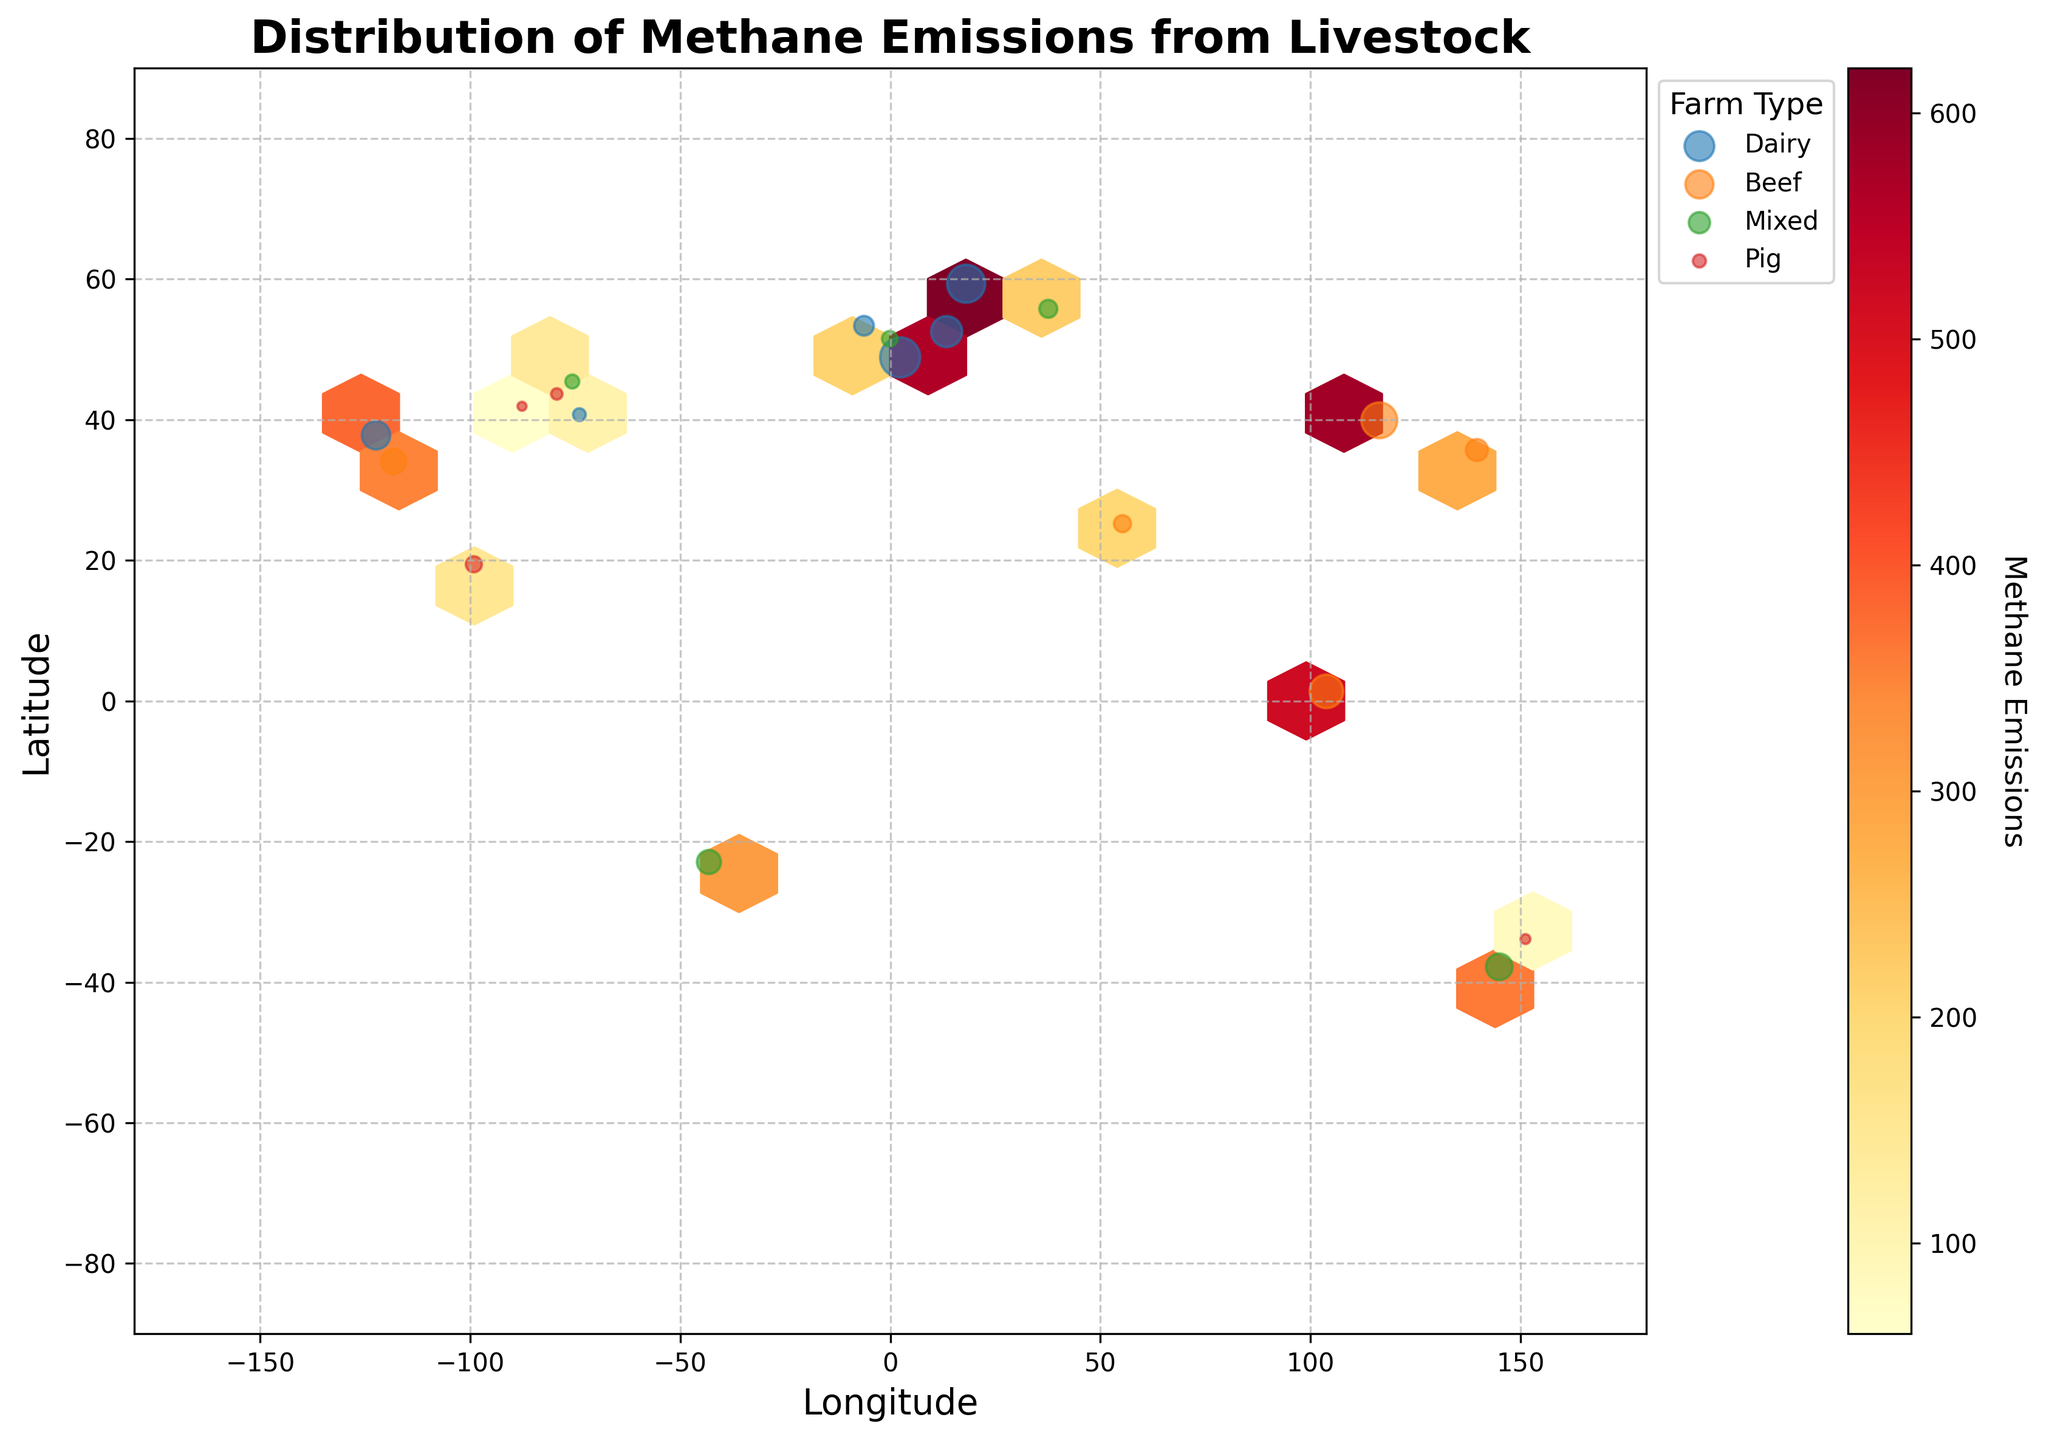What type of farms are represented in the figure? By looking at the legend of the plot, we can see that the farm types indicated are Dairy, Beef, Mixed, and Pig.
Answer: Dairy, Beef, Mixed, Pig What does the color intensity in the Hexbin plot indicate? The color intensity in the Hexbin plot represents the level of methane emissions. The color bar on the right side of the plot ranges from lighter to darker shades, signifying increasing levels of methane emissions.
Answer: Methane emission levels Which farm type primarily has farms with the highest methane emissions? By observing the larger markers and darker color hexagons in the plot, we can identify that Dairy farms are associated with the highest methane emissions.
Answer: Dairy How do methane emissions vary with farm size for Beef farms? By analyzing the scatter points labeled 'Beef', there is a trend where larger Beef farms tend to have higher methane emissions, visible by the larger circle markers over darker-colored hexagons.
Answer: Larger Beef farms have higher emissions Which region (latitude range) has the densest cluster of farms? Looking at the distribution of farms, most markers are densely clustered around latitudes between 20° and 60° (both North and South).
Answer: 20° to 60° Are there more high-emission or low-emission farms globally? The predominance of lighter-colored hexagons compared to darker ones suggests there are more low-emission farms globally.
Answer: More low-emission farms What can you infer about the methane emissions from Mixed farms? Scatter points representing Mixed farms, sized proportionally to farm size, indicate that they tend to have moderate levels of methane emissions, falling between Pig and Dairy/Beef farms.
Answer: Moderate emissions How do Pig farms compare to Mixed farms in terms of methane emissions? By comparing the scatter points for Pig and Mixed farms, Pig farms generally have smaller markers and are over lighter hexagons, indicating lower methane emissions compared to Mixed farms.
Answer: Pig farms have lower emissions 